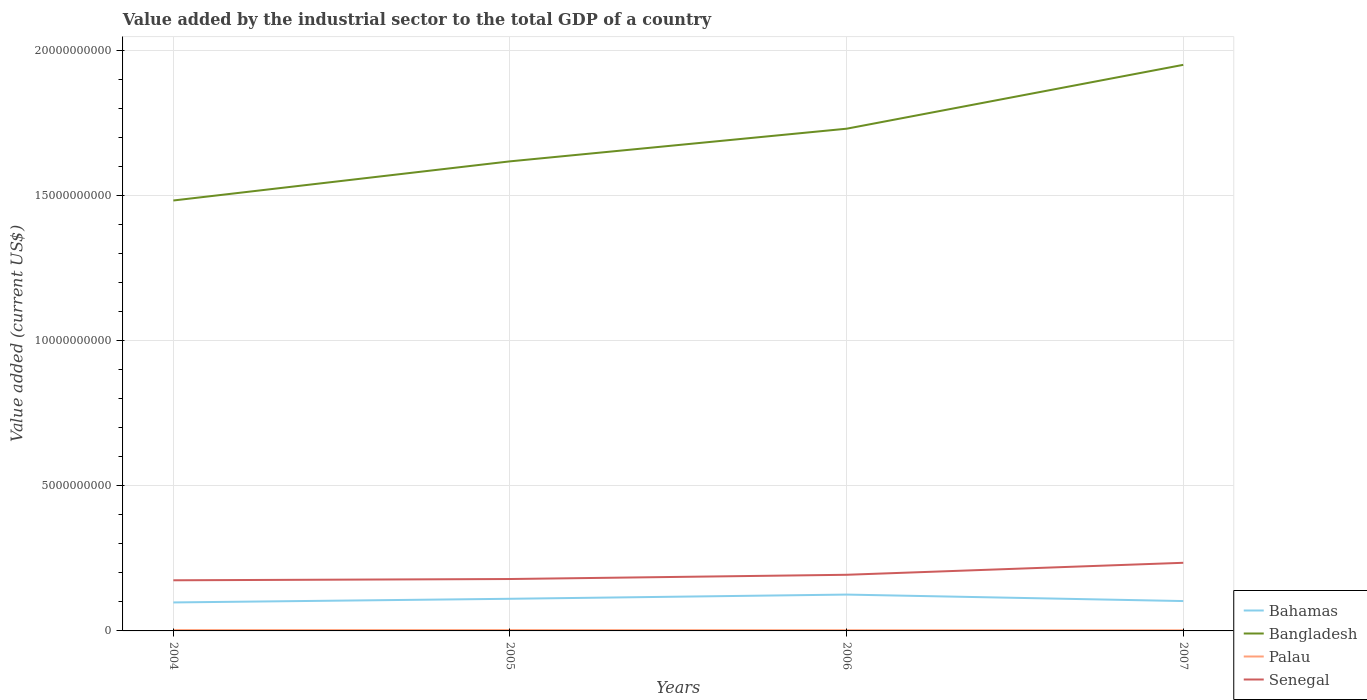How many different coloured lines are there?
Keep it short and to the point. 4. Across all years, what is the maximum value added by the industrial sector to the total GDP in Bangladesh?
Offer a very short reply. 1.48e+1. In which year was the value added by the industrial sector to the total GDP in Bangladesh maximum?
Offer a terse response. 2004. What is the total value added by the industrial sector to the total GDP in Senegal in the graph?
Ensure brevity in your answer.  -5.59e+08. What is the difference between the highest and the second highest value added by the industrial sector to the total GDP in Senegal?
Make the answer very short. 6.03e+08. Is the value added by the industrial sector to the total GDP in Palau strictly greater than the value added by the industrial sector to the total GDP in Bahamas over the years?
Your response must be concise. Yes. How many years are there in the graph?
Ensure brevity in your answer.  4. Are the values on the major ticks of Y-axis written in scientific E-notation?
Give a very brief answer. No. Does the graph contain any zero values?
Make the answer very short. No. What is the title of the graph?
Provide a succinct answer. Value added by the industrial sector to the total GDP of a country. Does "Europe(all income levels)" appear as one of the legend labels in the graph?
Your response must be concise. No. What is the label or title of the Y-axis?
Provide a succinct answer. Value added (current US$). What is the Value added (current US$) of Bahamas in 2004?
Give a very brief answer. 9.82e+08. What is the Value added (current US$) in Bangladesh in 2004?
Your response must be concise. 1.48e+1. What is the Value added (current US$) of Palau in 2004?
Provide a succinct answer. 2.89e+07. What is the Value added (current US$) of Senegal in 2004?
Give a very brief answer. 1.75e+09. What is the Value added (current US$) of Bahamas in 2005?
Offer a terse response. 1.11e+09. What is the Value added (current US$) in Bangladesh in 2005?
Your response must be concise. 1.62e+1. What is the Value added (current US$) of Palau in 2005?
Provide a succinct answer. 2.92e+07. What is the Value added (current US$) in Senegal in 2005?
Your answer should be very brief. 1.79e+09. What is the Value added (current US$) of Bahamas in 2006?
Offer a very short reply. 1.25e+09. What is the Value added (current US$) in Bangladesh in 2006?
Make the answer very short. 1.73e+1. What is the Value added (current US$) in Palau in 2006?
Ensure brevity in your answer.  2.43e+07. What is the Value added (current US$) in Senegal in 2006?
Provide a short and direct response. 1.93e+09. What is the Value added (current US$) in Bahamas in 2007?
Provide a succinct answer. 1.03e+09. What is the Value added (current US$) of Bangladesh in 2007?
Give a very brief answer. 1.95e+1. What is the Value added (current US$) of Palau in 2007?
Your answer should be compact. 2.17e+07. What is the Value added (current US$) in Senegal in 2007?
Your answer should be compact. 2.35e+09. Across all years, what is the maximum Value added (current US$) of Bahamas?
Keep it short and to the point. 1.25e+09. Across all years, what is the maximum Value added (current US$) of Bangladesh?
Ensure brevity in your answer.  1.95e+1. Across all years, what is the maximum Value added (current US$) in Palau?
Ensure brevity in your answer.  2.92e+07. Across all years, what is the maximum Value added (current US$) of Senegal?
Ensure brevity in your answer.  2.35e+09. Across all years, what is the minimum Value added (current US$) of Bahamas?
Your answer should be very brief. 9.82e+08. Across all years, what is the minimum Value added (current US$) of Bangladesh?
Your answer should be very brief. 1.48e+1. Across all years, what is the minimum Value added (current US$) of Palau?
Your answer should be compact. 2.17e+07. Across all years, what is the minimum Value added (current US$) in Senegal?
Your answer should be very brief. 1.75e+09. What is the total Value added (current US$) in Bahamas in the graph?
Offer a terse response. 4.37e+09. What is the total Value added (current US$) of Bangladesh in the graph?
Make the answer very short. 6.78e+1. What is the total Value added (current US$) in Palau in the graph?
Give a very brief answer. 1.04e+08. What is the total Value added (current US$) of Senegal in the graph?
Keep it short and to the point. 7.82e+09. What is the difference between the Value added (current US$) in Bahamas in 2004 and that in 2005?
Make the answer very short. -1.26e+08. What is the difference between the Value added (current US$) of Bangladesh in 2004 and that in 2005?
Provide a short and direct response. -1.35e+09. What is the difference between the Value added (current US$) in Palau in 2004 and that in 2005?
Provide a short and direct response. -3.66e+05. What is the difference between the Value added (current US$) in Senegal in 2004 and that in 2005?
Make the answer very short. -4.35e+07. What is the difference between the Value added (current US$) of Bahamas in 2004 and that in 2006?
Ensure brevity in your answer.  -2.71e+08. What is the difference between the Value added (current US$) of Bangladesh in 2004 and that in 2006?
Offer a terse response. -2.47e+09. What is the difference between the Value added (current US$) in Palau in 2004 and that in 2006?
Give a very brief answer. 4.58e+06. What is the difference between the Value added (current US$) of Senegal in 2004 and that in 2006?
Offer a very short reply. -1.89e+08. What is the difference between the Value added (current US$) in Bahamas in 2004 and that in 2007?
Offer a very short reply. -4.74e+07. What is the difference between the Value added (current US$) in Bangladesh in 2004 and that in 2007?
Make the answer very short. -4.67e+09. What is the difference between the Value added (current US$) of Palau in 2004 and that in 2007?
Your answer should be very brief. 7.16e+06. What is the difference between the Value added (current US$) of Senegal in 2004 and that in 2007?
Your answer should be compact. -6.03e+08. What is the difference between the Value added (current US$) of Bahamas in 2005 and that in 2006?
Offer a very short reply. -1.45e+08. What is the difference between the Value added (current US$) in Bangladesh in 2005 and that in 2006?
Offer a terse response. -1.12e+09. What is the difference between the Value added (current US$) of Palau in 2005 and that in 2006?
Keep it short and to the point. 4.95e+06. What is the difference between the Value added (current US$) in Senegal in 2005 and that in 2006?
Provide a succinct answer. -1.46e+08. What is the difference between the Value added (current US$) in Bahamas in 2005 and that in 2007?
Your answer should be very brief. 7.83e+07. What is the difference between the Value added (current US$) in Bangladesh in 2005 and that in 2007?
Provide a succinct answer. -3.33e+09. What is the difference between the Value added (current US$) in Palau in 2005 and that in 2007?
Keep it short and to the point. 7.52e+06. What is the difference between the Value added (current US$) of Senegal in 2005 and that in 2007?
Provide a short and direct response. -5.59e+08. What is the difference between the Value added (current US$) of Bahamas in 2006 and that in 2007?
Ensure brevity in your answer.  2.23e+08. What is the difference between the Value added (current US$) in Bangladesh in 2006 and that in 2007?
Your answer should be very brief. -2.20e+09. What is the difference between the Value added (current US$) of Palau in 2006 and that in 2007?
Offer a very short reply. 2.57e+06. What is the difference between the Value added (current US$) of Senegal in 2006 and that in 2007?
Ensure brevity in your answer.  -4.13e+08. What is the difference between the Value added (current US$) in Bahamas in 2004 and the Value added (current US$) in Bangladesh in 2005?
Offer a terse response. -1.52e+1. What is the difference between the Value added (current US$) of Bahamas in 2004 and the Value added (current US$) of Palau in 2005?
Your response must be concise. 9.52e+08. What is the difference between the Value added (current US$) of Bahamas in 2004 and the Value added (current US$) of Senegal in 2005?
Make the answer very short. -8.07e+08. What is the difference between the Value added (current US$) of Bangladesh in 2004 and the Value added (current US$) of Palau in 2005?
Provide a succinct answer. 1.48e+1. What is the difference between the Value added (current US$) in Bangladesh in 2004 and the Value added (current US$) in Senegal in 2005?
Keep it short and to the point. 1.30e+1. What is the difference between the Value added (current US$) of Palau in 2004 and the Value added (current US$) of Senegal in 2005?
Your response must be concise. -1.76e+09. What is the difference between the Value added (current US$) in Bahamas in 2004 and the Value added (current US$) in Bangladesh in 2006?
Give a very brief answer. -1.63e+1. What is the difference between the Value added (current US$) in Bahamas in 2004 and the Value added (current US$) in Palau in 2006?
Your answer should be compact. 9.57e+08. What is the difference between the Value added (current US$) in Bahamas in 2004 and the Value added (current US$) in Senegal in 2006?
Offer a terse response. -9.53e+08. What is the difference between the Value added (current US$) of Bangladesh in 2004 and the Value added (current US$) of Palau in 2006?
Your response must be concise. 1.48e+1. What is the difference between the Value added (current US$) of Bangladesh in 2004 and the Value added (current US$) of Senegal in 2006?
Your answer should be compact. 1.29e+1. What is the difference between the Value added (current US$) of Palau in 2004 and the Value added (current US$) of Senegal in 2006?
Provide a succinct answer. -1.91e+09. What is the difference between the Value added (current US$) of Bahamas in 2004 and the Value added (current US$) of Bangladesh in 2007?
Give a very brief answer. -1.85e+1. What is the difference between the Value added (current US$) in Bahamas in 2004 and the Value added (current US$) in Palau in 2007?
Make the answer very short. 9.60e+08. What is the difference between the Value added (current US$) of Bahamas in 2004 and the Value added (current US$) of Senegal in 2007?
Your answer should be compact. -1.37e+09. What is the difference between the Value added (current US$) of Bangladesh in 2004 and the Value added (current US$) of Palau in 2007?
Provide a succinct answer. 1.48e+1. What is the difference between the Value added (current US$) of Bangladesh in 2004 and the Value added (current US$) of Senegal in 2007?
Your answer should be compact. 1.25e+1. What is the difference between the Value added (current US$) of Palau in 2004 and the Value added (current US$) of Senegal in 2007?
Keep it short and to the point. -2.32e+09. What is the difference between the Value added (current US$) of Bahamas in 2005 and the Value added (current US$) of Bangladesh in 2006?
Offer a very short reply. -1.62e+1. What is the difference between the Value added (current US$) of Bahamas in 2005 and the Value added (current US$) of Palau in 2006?
Provide a succinct answer. 1.08e+09. What is the difference between the Value added (current US$) of Bahamas in 2005 and the Value added (current US$) of Senegal in 2006?
Offer a terse response. -8.27e+08. What is the difference between the Value added (current US$) in Bangladesh in 2005 and the Value added (current US$) in Palau in 2006?
Give a very brief answer. 1.62e+1. What is the difference between the Value added (current US$) in Bangladesh in 2005 and the Value added (current US$) in Senegal in 2006?
Your answer should be very brief. 1.42e+1. What is the difference between the Value added (current US$) of Palau in 2005 and the Value added (current US$) of Senegal in 2006?
Offer a terse response. -1.91e+09. What is the difference between the Value added (current US$) in Bahamas in 2005 and the Value added (current US$) in Bangladesh in 2007?
Give a very brief answer. -1.84e+1. What is the difference between the Value added (current US$) of Bahamas in 2005 and the Value added (current US$) of Palau in 2007?
Your response must be concise. 1.09e+09. What is the difference between the Value added (current US$) of Bahamas in 2005 and the Value added (current US$) of Senegal in 2007?
Make the answer very short. -1.24e+09. What is the difference between the Value added (current US$) of Bangladesh in 2005 and the Value added (current US$) of Palau in 2007?
Offer a very short reply. 1.62e+1. What is the difference between the Value added (current US$) of Bangladesh in 2005 and the Value added (current US$) of Senegal in 2007?
Offer a very short reply. 1.38e+1. What is the difference between the Value added (current US$) in Palau in 2005 and the Value added (current US$) in Senegal in 2007?
Offer a terse response. -2.32e+09. What is the difference between the Value added (current US$) of Bahamas in 2006 and the Value added (current US$) of Bangladesh in 2007?
Give a very brief answer. -1.83e+1. What is the difference between the Value added (current US$) of Bahamas in 2006 and the Value added (current US$) of Palau in 2007?
Keep it short and to the point. 1.23e+09. What is the difference between the Value added (current US$) in Bahamas in 2006 and the Value added (current US$) in Senegal in 2007?
Offer a very short reply. -1.10e+09. What is the difference between the Value added (current US$) of Bangladesh in 2006 and the Value added (current US$) of Palau in 2007?
Ensure brevity in your answer.  1.73e+1. What is the difference between the Value added (current US$) in Bangladesh in 2006 and the Value added (current US$) in Senegal in 2007?
Keep it short and to the point. 1.50e+1. What is the difference between the Value added (current US$) of Palau in 2006 and the Value added (current US$) of Senegal in 2007?
Ensure brevity in your answer.  -2.32e+09. What is the average Value added (current US$) of Bahamas per year?
Your answer should be very brief. 1.09e+09. What is the average Value added (current US$) in Bangladesh per year?
Your answer should be compact. 1.70e+1. What is the average Value added (current US$) of Palau per year?
Your response must be concise. 2.60e+07. What is the average Value added (current US$) of Senegal per year?
Ensure brevity in your answer.  1.95e+09. In the year 2004, what is the difference between the Value added (current US$) in Bahamas and Value added (current US$) in Bangladesh?
Offer a terse response. -1.39e+1. In the year 2004, what is the difference between the Value added (current US$) in Bahamas and Value added (current US$) in Palau?
Your answer should be very brief. 9.53e+08. In the year 2004, what is the difference between the Value added (current US$) in Bahamas and Value added (current US$) in Senegal?
Provide a short and direct response. -7.63e+08. In the year 2004, what is the difference between the Value added (current US$) in Bangladesh and Value added (current US$) in Palau?
Offer a terse response. 1.48e+1. In the year 2004, what is the difference between the Value added (current US$) in Bangladesh and Value added (current US$) in Senegal?
Give a very brief answer. 1.31e+1. In the year 2004, what is the difference between the Value added (current US$) in Palau and Value added (current US$) in Senegal?
Give a very brief answer. -1.72e+09. In the year 2005, what is the difference between the Value added (current US$) of Bahamas and Value added (current US$) of Bangladesh?
Provide a short and direct response. -1.51e+1. In the year 2005, what is the difference between the Value added (current US$) of Bahamas and Value added (current US$) of Palau?
Ensure brevity in your answer.  1.08e+09. In the year 2005, what is the difference between the Value added (current US$) of Bahamas and Value added (current US$) of Senegal?
Offer a terse response. -6.81e+08. In the year 2005, what is the difference between the Value added (current US$) in Bangladesh and Value added (current US$) in Palau?
Offer a terse response. 1.62e+1. In the year 2005, what is the difference between the Value added (current US$) of Bangladesh and Value added (current US$) of Senegal?
Provide a short and direct response. 1.44e+1. In the year 2005, what is the difference between the Value added (current US$) of Palau and Value added (current US$) of Senegal?
Your answer should be compact. -1.76e+09. In the year 2006, what is the difference between the Value added (current US$) of Bahamas and Value added (current US$) of Bangladesh?
Your response must be concise. -1.61e+1. In the year 2006, what is the difference between the Value added (current US$) of Bahamas and Value added (current US$) of Palau?
Provide a succinct answer. 1.23e+09. In the year 2006, what is the difference between the Value added (current US$) of Bahamas and Value added (current US$) of Senegal?
Your response must be concise. -6.82e+08. In the year 2006, what is the difference between the Value added (current US$) of Bangladesh and Value added (current US$) of Palau?
Keep it short and to the point. 1.73e+1. In the year 2006, what is the difference between the Value added (current US$) in Bangladesh and Value added (current US$) in Senegal?
Provide a succinct answer. 1.54e+1. In the year 2006, what is the difference between the Value added (current US$) of Palau and Value added (current US$) of Senegal?
Offer a very short reply. -1.91e+09. In the year 2007, what is the difference between the Value added (current US$) of Bahamas and Value added (current US$) of Bangladesh?
Provide a short and direct response. -1.85e+1. In the year 2007, what is the difference between the Value added (current US$) in Bahamas and Value added (current US$) in Palau?
Keep it short and to the point. 1.01e+09. In the year 2007, what is the difference between the Value added (current US$) in Bahamas and Value added (current US$) in Senegal?
Make the answer very short. -1.32e+09. In the year 2007, what is the difference between the Value added (current US$) in Bangladesh and Value added (current US$) in Palau?
Your answer should be compact. 1.95e+1. In the year 2007, what is the difference between the Value added (current US$) of Bangladesh and Value added (current US$) of Senegal?
Provide a succinct answer. 1.72e+1. In the year 2007, what is the difference between the Value added (current US$) of Palau and Value added (current US$) of Senegal?
Keep it short and to the point. -2.33e+09. What is the ratio of the Value added (current US$) of Bahamas in 2004 to that in 2005?
Your answer should be compact. 0.89. What is the ratio of the Value added (current US$) in Bangladesh in 2004 to that in 2005?
Your answer should be compact. 0.92. What is the ratio of the Value added (current US$) of Palau in 2004 to that in 2005?
Make the answer very short. 0.99. What is the ratio of the Value added (current US$) of Senegal in 2004 to that in 2005?
Offer a very short reply. 0.98. What is the ratio of the Value added (current US$) in Bahamas in 2004 to that in 2006?
Provide a short and direct response. 0.78. What is the ratio of the Value added (current US$) in Palau in 2004 to that in 2006?
Offer a terse response. 1.19. What is the ratio of the Value added (current US$) in Senegal in 2004 to that in 2006?
Make the answer very short. 0.9. What is the ratio of the Value added (current US$) in Bahamas in 2004 to that in 2007?
Provide a short and direct response. 0.95. What is the ratio of the Value added (current US$) in Bangladesh in 2004 to that in 2007?
Provide a succinct answer. 0.76. What is the ratio of the Value added (current US$) of Palau in 2004 to that in 2007?
Give a very brief answer. 1.33. What is the ratio of the Value added (current US$) of Senegal in 2004 to that in 2007?
Provide a succinct answer. 0.74. What is the ratio of the Value added (current US$) of Bahamas in 2005 to that in 2006?
Give a very brief answer. 0.88. What is the ratio of the Value added (current US$) in Bangladesh in 2005 to that in 2006?
Offer a very short reply. 0.94. What is the ratio of the Value added (current US$) of Palau in 2005 to that in 2006?
Offer a very short reply. 1.2. What is the ratio of the Value added (current US$) of Senegal in 2005 to that in 2006?
Your answer should be compact. 0.92. What is the ratio of the Value added (current US$) of Bahamas in 2005 to that in 2007?
Provide a short and direct response. 1.08. What is the ratio of the Value added (current US$) of Bangladesh in 2005 to that in 2007?
Your response must be concise. 0.83. What is the ratio of the Value added (current US$) in Palau in 2005 to that in 2007?
Give a very brief answer. 1.35. What is the ratio of the Value added (current US$) of Senegal in 2005 to that in 2007?
Offer a terse response. 0.76. What is the ratio of the Value added (current US$) of Bahamas in 2006 to that in 2007?
Give a very brief answer. 1.22. What is the ratio of the Value added (current US$) of Bangladesh in 2006 to that in 2007?
Offer a terse response. 0.89. What is the ratio of the Value added (current US$) in Palau in 2006 to that in 2007?
Provide a succinct answer. 1.12. What is the ratio of the Value added (current US$) of Senegal in 2006 to that in 2007?
Offer a very short reply. 0.82. What is the difference between the highest and the second highest Value added (current US$) in Bahamas?
Your response must be concise. 1.45e+08. What is the difference between the highest and the second highest Value added (current US$) of Bangladesh?
Make the answer very short. 2.20e+09. What is the difference between the highest and the second highest Value added (current US$) of Palau?
Offer a very short reply. 3.66e+05. What is the difference between the highest and the second highest Value added (current US$) in Senegal?
Your response must be concise. 4.13e+08. What is the difference between the highest and the lowest Value added (current US$) of Bahamas?
Keep it short and to the point. 2.71e+08. What is the difference between the highest and the lowest Value added (current US$) in Bangladesh?
Give a very brief answer. 4.67e+09. What is the difference between the highest and the lowest Value added (current US$) of Palau?
Make the answer very short. 7.52e+06. What is the difference between the highest and the lowest Value added (current US$) in Senegal?
Keep it short and to the point. 6.03e+08. 